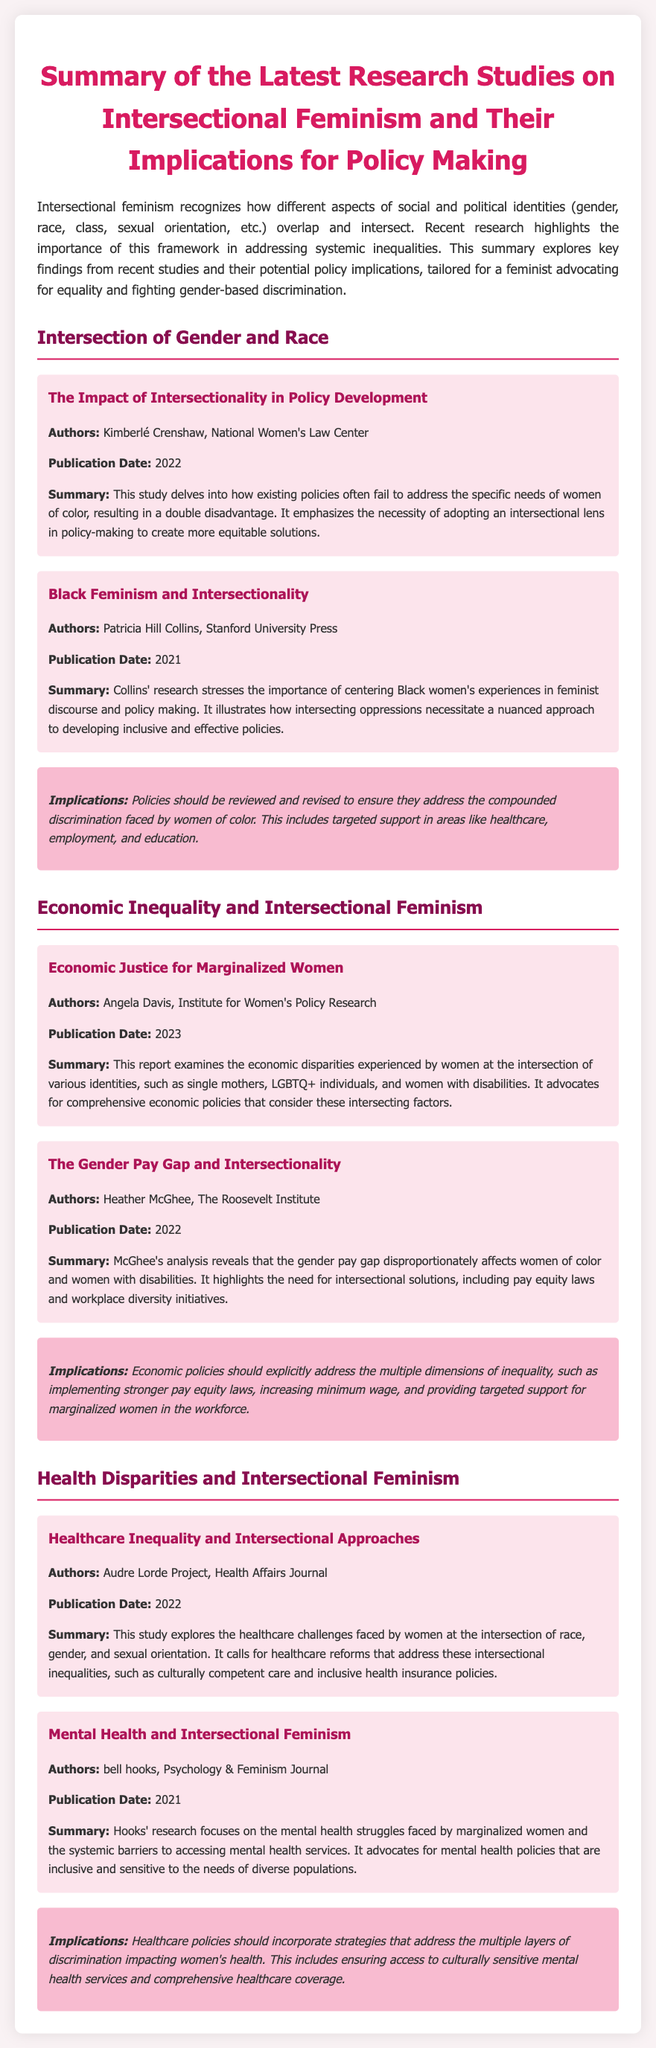What is the title of the summary? The title of the summary is specified at the beginning of the document, which encapsulates the main topic of intersectional feminism and policy making.
Answer: Summary of the Latest Research Studies on Intersectional Feminism and Their Implications for Policy Making Who is the author of the study "The Impact of Intersectionality in Policy Development"? The document provides the names of authors for each study, indicating that Kimberlé Crenshaw is the author of this study.
Answer: Kimberlé Crenshaw What year was "Economic Justice for Marginalized Women" published? The publication date for each study is outlined, showing that this report was published in 2023.
Answer: 2023 What type of policies does the study by Angela Davis advocate for? The study highlights specific policy needs for marginalized women concerning economic justice, indicating a focus on comprehensive economic policies.
Answer: Comprehensive economic policies How does the document describe the intersection of gender and race? The research findings in this section discuss unique challenges faced by women of color, emphasizing the need for an intersectional lens in policy-making.
Answer: Compounded discrimination What implications are suggested for health care policies? The document outlines specific recommendations related to healthcare, particularly addressing multiple layers of discrimination impacting women's health.
Answer: Culturally sensitive mental health services Who published the study "Black Feminism and Intersectionality"? The author's affiliation with a reputable institution is noted, revealing that it was published by Stanford University Press.
Answer: Stanford University Press What color theme is predominantly used in the document? The visual design choices reflect a specific aesthetic, which includes a color theme that relies on shades of pink and purple.
Answer: Pink and purple 